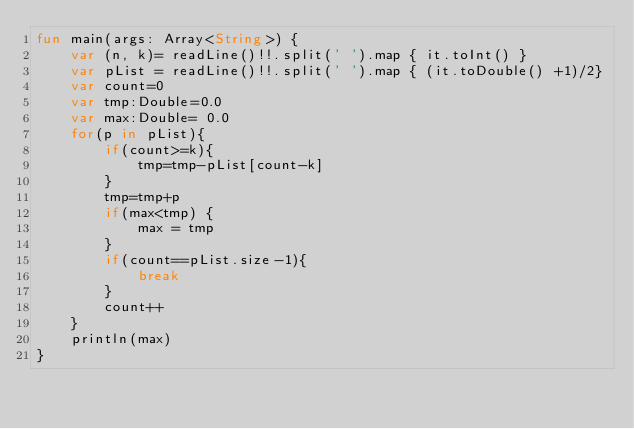<code> <loc_0><loc_0><loc_500><loc_500><_Kotlin_>fun main(args: Array<String>) {
    var (n, k)= readLine()!!.split(' ').map { it.toInt() }
    var pList = readLine()!!.split(' ').map { (it.toDouble() +1)/2}
    var count=0
    var tmp:Double=0.0
    var max:Double= 0.0
    for(p in pList){
        if(count>=k){
            tmp=tmp-pList[count-k]
        }
        tmp=tmp+p
        if(max<tmp) {
            max = tmp
        }
        if(count==pList.size-1){
            break
        }
        count++
    }
    println(max)
}
</code> 